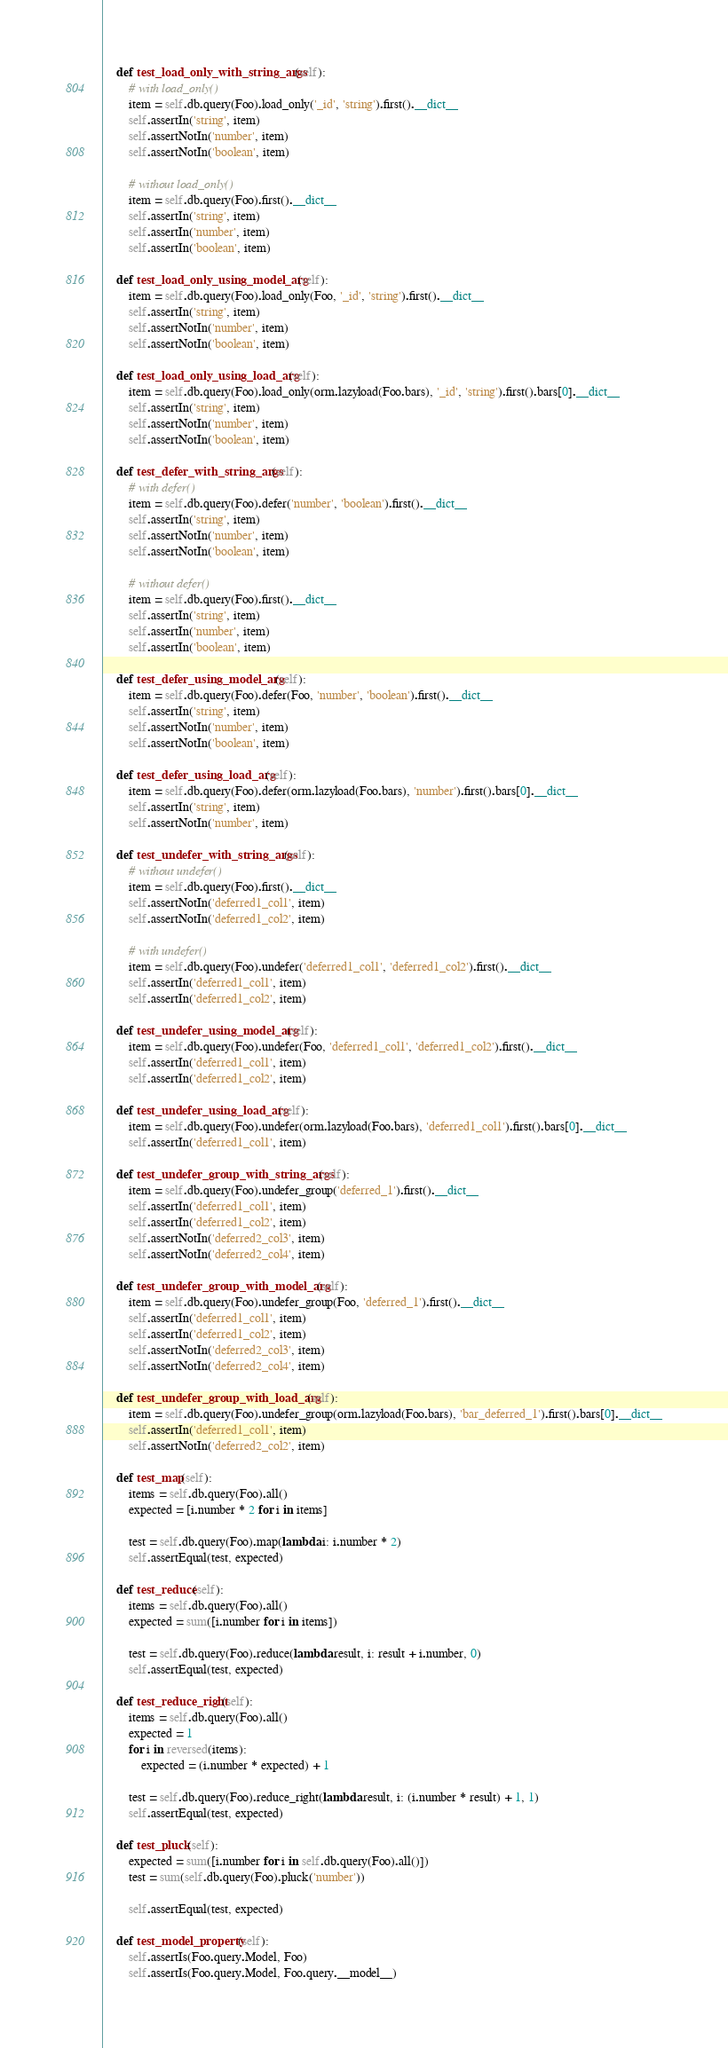Convert code to text. <code><loc_0><loc_0><loc_500><loc_500><_Python_>    def test_load_only_with_string_args(self):
        # with load_only()
        item = self.db.query(Foo).load_only('_id', 'string').first().__dict__
        self.assertIn('string', item)
        self.assertNotIn('number', item)
        self.assertNotIn('boolean', item)

        # without load_only()
        item = self.db.query(Foo).first().__dict__
        self.assertIn('string', item)
        self.assertIn('number', item)
        self.assertIn('boolean', item)

    def test_load_only_using_model_arg(self):
        item = self.db.query(Foo).load_only(Foo, '_id', 'string').first().__dict__
        self.assertIn('string', item)
        self.assertNotIn('number', item)
        self.assertNotIn('boolean', item)

    def test_load_only_using_load_arg(self):
        item = self.db.query(Foo).load_only(orm.lazyload(Foo.bars), '_id', 'string').first().bars[0].__dict__
        self.assertIn('string', item)
        self.assertNotIn('number', item)
        self.assertNotIn('boolean', item)

    def test_defer_with_string_args(self):
        # with defer()
        item = self.db.query(Foo).defer('number', 'boolean').first().__dict__
        self.assertIn('string', item)
        self.assertNotIn('number', item)
        self.assertNotIn('boolean', item)

        # without defer()
        item = self.db.query(Foo).first().__dict__
        self.assertIn('string', item)
        self.assertIn('number', item)
        self.assertIn('boolean', item)

    def test_defer_using_model_arg(self):
        item = self.db.query(Foo).defer(Foo, 'number', 'boolean').first().__dict__
        self.assertIn('string', item)
        self.assertNotIn('number', item)
        self.assertNotIn('boolean', item)

    def test_defer_using_load_arg(self):
        item = self.db.query(Foo).defer(orm.lazyload(Foo.bars), 'number').first().bars[0].__dict__
        self.assertIn('string', item)
        self.assertNotIn('number', item)

    def test_undefer_with_string_args(self):
        # without undefer()
        item = self.db.query(Foo).first().__dict__
        self.assertNotIn('deferred1_col1', item)
        self.assertNotIn('deferred1_col2', item)

        # with undefer()
        item = self.db.query(Foo).undefer('deferred1_col1', 'deferred1_col2').first().__dict__
        self.assertIn('deferred1_col1', item)
        self.assertIn('deferred1_col2', item)

    def test_undefer_using_model_arg(self):
        item = self.db.query(Foo).undefer(Foo, 'deferred1_col1', 'deferred1_col2').first().__dict__
        self.assertIn('deferred1_col1', item)
        self.assertIn('deferred1_col2', item)

    def test_undefer_using_load_arg(self):
        item = self.db.query(Foo).undefer(orm.lazyload(Foo.bars), 'deferred1_col1').first().bars[0].__dict__
        self.assertIn('deferred1_col1', item)

    def test_undefer_group_with_string_args(self):
        item = self.db.query(Foo).undefer_group('deferred_1').first().__dict__
        self.assertIn('deferred1_col1', item)
        self.assertIn('deferred1_col2', item)
        self.assertNotIn('deferred2_col3', item)
        self.assertNotIn('deferred2_col4', item)

    def test_undefer_group_with_model_arg(self):
        item = self.db.query(Foo).undefer_group(Foo, 'deferred_1').first().__dict__
        self.assertIn('deferred1_col1', item)
        self.assertIn('deferred1_col2', item)
        self.assertNotIn('deferred2_col3', item)
        self.assertNotIn('deferred2_col4', item)

    def test_undefer_group_with_load_arg(self):
        item = self.db.query(Foo).undefer_group(orm.lazyload(Foo.bars), 'bar_deferred_1').first().bars[0].__dict__
        self.assertIn('deferred1_col1', item)
        self.assertNotIn('deferred2_col2', item)

    def test_map(self):
        items = self.db.query(Foo).all()
        expected = [i.number * 2 for i in items]

        test = self.db.query(Foo).map(lambda i: i.number * 2)
        self.assertEqual(test, expected)

    def test_reduce(self):
        items = self.db.query(Foo).all()
        expected = sum([i.number for i in items])

        test = self.db.query(Foo).reduce(lambda result, i: result + i.number, 0)
        self.assertEqual(test, expected)

    def test_reduce_right(self):
        items = self.db.query(Foo).all()
        expected = 1
        for i in reversed(items):
            expected = (i.number * expected) + 1

        test = self.db.query(Foo).reduce_right(lambda result, i: (i.number * result) + 1, 1)
        self.assertEqual(test, expected)

    def test_pluck(self):
        expected = sum([i.number for i in self.db.query(Foo).all()])
        test = sum(self.db.query(Foo).pluck('number'))

        self.assertEqual(test, expected)

    def test_model_property(self):
        self.assertIs(Foo.query.Model, Foo)
        self.assertIs(Foo.query.Model, Foo.query.__model__)
</code> 